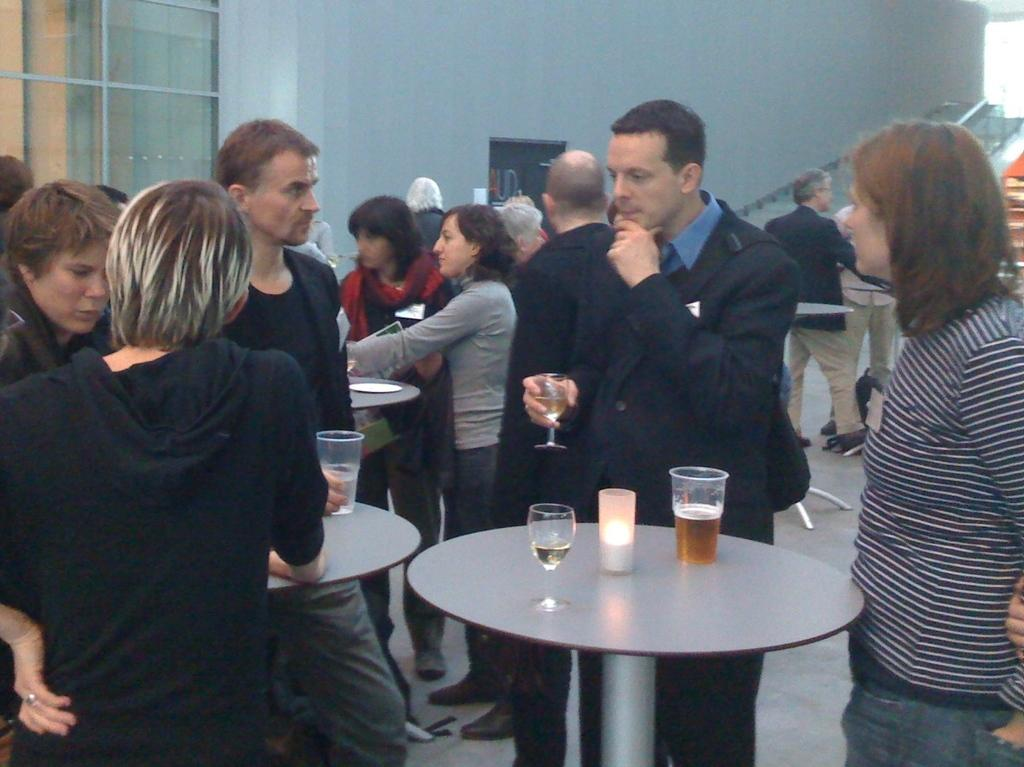How many people are present in the image? There are people standing in the image. Can you describe what one of the people is holding? One person is holding a wine glass in his hand. What type of badge is the sister wearing in the image? There is no mention of a sister or a badge in the image. 